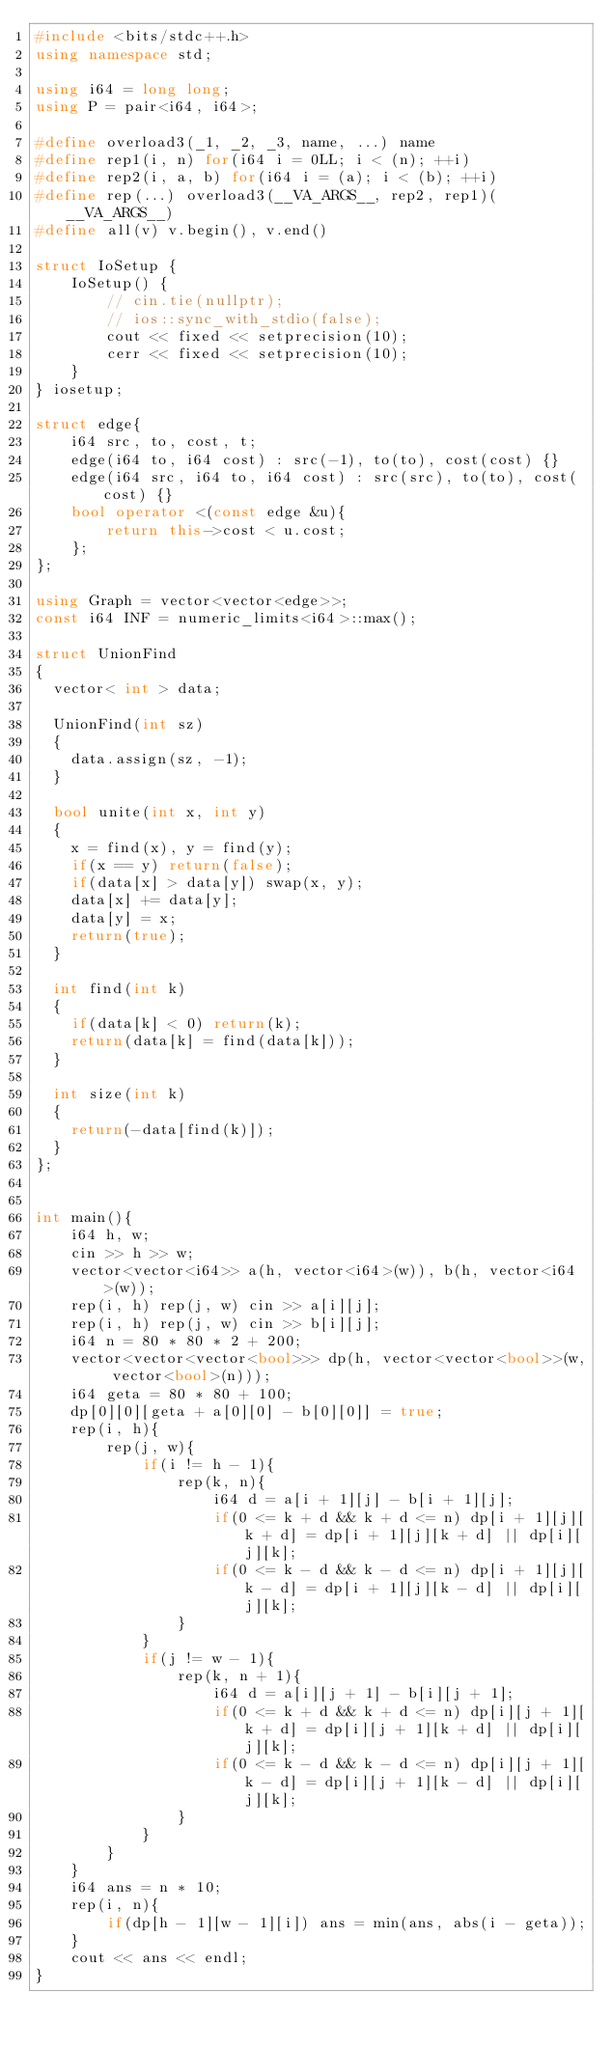Convert code to text. <code><loc_0><loc_0><loc_500><loc_500><_C++_>#include <bits/stdc++.h>
using namespace std;

using i64 = long long;
using P = pair<i64, i64>;

#define overload3(_1, _2, _3, name, ...) name
#define rep1(i, n) for(i64 i = 0LL; i < (n); ++i)
#define rep2(i, a, b) for(i64 i = (a); i < (b); ++i)
#define rep(...) overload3(__VA_ARGS__, rep2, rep1)(__VA_ARGS__)
#define all(v) v.begin(), v.end()

struct IoSetup {
    IoSetup() {
        // cin.tie(nullptr);
        // ios::sync_with_stdio(false);
        cout << fixed << setprecision(10);
        cerr << fixed << setprecision(10);
    }
} iosetup;

struct edge{
    i64 src, to, cost, t;
    edge(i64 to, i64 cost) : src(-1), to(to), cost(cost) {}
    edge(i64 src, i64 to, i64 cost) : src(src), to(to), cost(cost) {}
    bool operator <(const edge &u){
        return this->cost < u.cost;
    };
};

using Graph = vector<vector<edge>>;
const i64 INF = numeric_limits<i64>::max();

struct UnionFind
{
  vector< int > data;

  UnionFind(int sz)
  {
    data.assign(sz, -1);
  }

  bool unite(int x, int y)
  {
    x = find(x), y = find(y);
    if(x == y) return(false);
    if(data[x] > data[y]) swap(x, y);
    data[x] += data[y];
    data[y] = x;
    return(true);
  }

  int find(int k)
  {
    if(data[k] < 0) return(k);
    return(data[k] = find(data[k]));
  }

  int size(int k)
  {
    return(-data[find(k)]);
  }
};


int main(){
    i64 h, w;
    cin >> h >> w;
    vector<vector<i64>> a(h, vector<i64>(w)), b(h, vector<i64>(w));
    rep(i, h) rep(j, w) cin >> a[i][j];
    rep(i, h) rep(j, w) cin >> b[i][j];
    i64 n = 80 * 80 * 2 + 200;
    vector<vector<vector<bool>>> dp(h, vector<vector<bool>>(w, vector<bool>(n)));
    i64 geta = 80 * 80 + 100;
    dp[0][0][geta + a[0][0] - b[0][0]] = true;
    rep(i, h){
        rep(j, w){
            if(i != h - 1){
                rep(k, n){
                    i64 d = a[i + 1][j] - b[i + 1][j];
                    if(0 <= k + d && k + d <= n) dp[i + 1][j][k + d] = dp[i + 1][j][k + d] || dp[i][j][k]; 
                    if(0 <= k - d && k - d <= n) dp[i + 1][j][k - d] = dp[i + 1][j][k - d] || dp[i][j][k]; 
                }
            }
            if(j != w - 1){
                rep(k, n + 1){
                    i64 d = a[i][j + 1] - b[i][j + 1];
                    if(0 <= k + d && k + d <= n) dp[i][j + 1][k + d] = dp[i][j + 1][k + d] || dp[i][j][k]; 
                    if(0 <= k - d && k - d <= n) dp[i][j + 1][k - d] = dp[i][j + 1][k - d] || dp[i][j][k]; 
                }
            }
        }
    }
    i64 ans = n * 10;
    rep(i, n){
        if(dp[h - 1][w - 1][i]) ans = min(ans, abs(i - geta));
    }
    cout << ans << endl;
}
</code> 